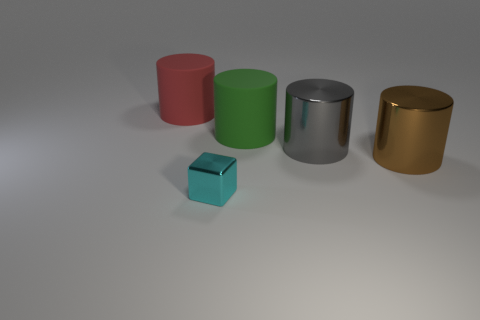Are there any other things that are the same shape as the small metallic object?
Offer a terse response. No. Are there more shiny objects to the left of the brown shiny cylinder than small blocks that are behind the green rubber cylinder?
Provide a succinct answer. Yes. How many things are either metal cubes or small purple blocks?
Offer a terse response. 1. What number of other objects are the same color as the tiny shiny block?
Offer a very short reply. 0. What is the shape of the brown thing that is the same size as the green thing?
Keep it short and to the point. Cylinder. There is a large rubber cylinder that is on the right side of the red matte cylinder; what is its color?
Keep it short and to the point. Green. What number of things are cylinders that are on the right side of the large red object or metal cylinders that are in front of the large gray object?
Your answer should be very brief. 3. Does the red rubber thing have the same size as the green rubber cylinder?
Keep it short and to the point. Yes. What number of cylinders are either small yellow metallic objects or small cyan objects?
Keep it short and to the point. 0. How many things are left of the green cylinder and behind the large brown shiny thing?
Make the answer very short. 1. 